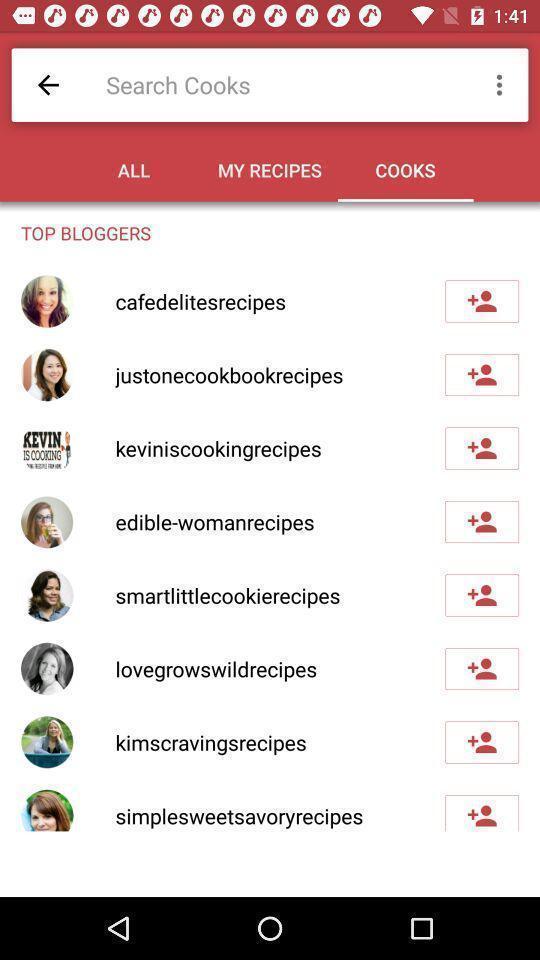Provide a detailed account of this screenshot. Page showing search bar to find different cooks. 